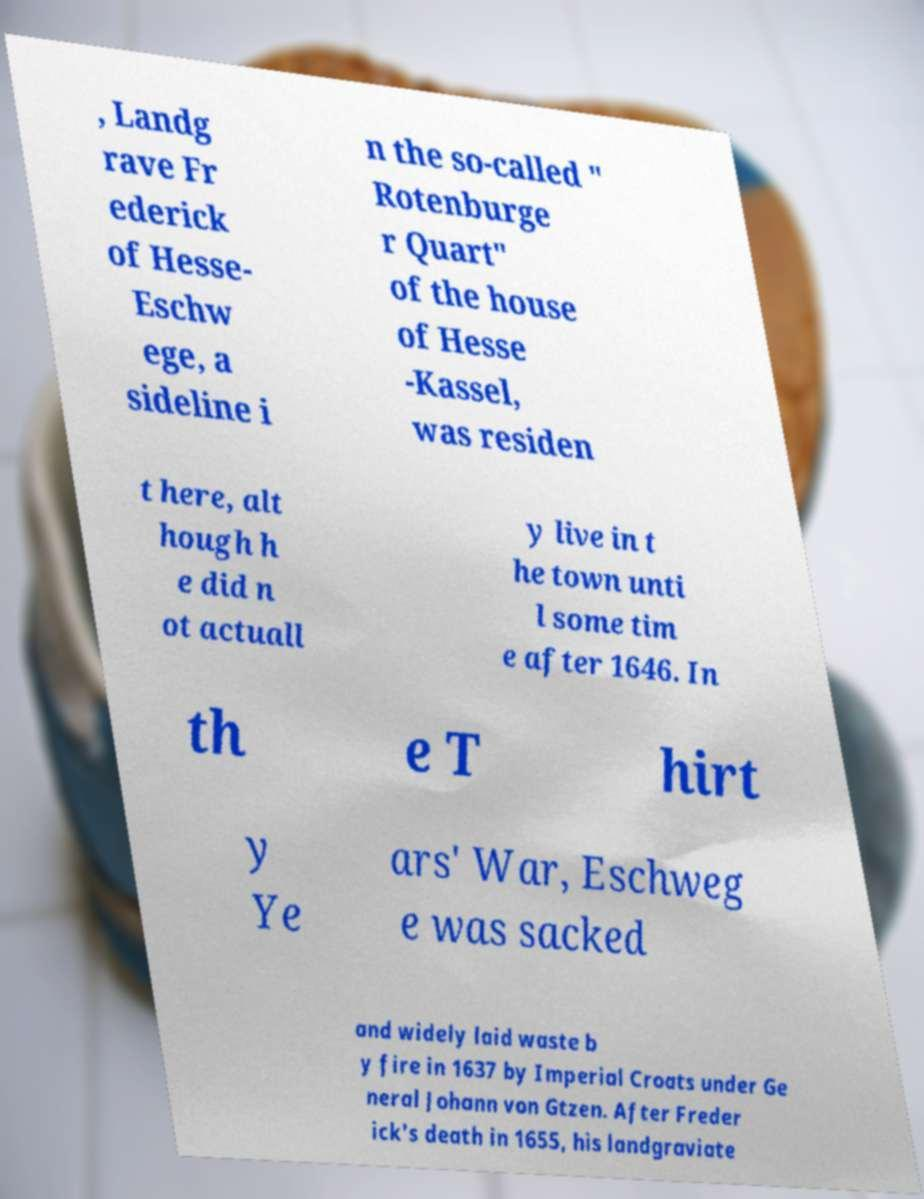I need the written content from this picture converted into text. Can you do that? , Landg rave Fr ederick of Hesse- Eschw ege, a sideline i n the so-called " Rotenburge r Quart" of the house of Hesse -Kassel, was residen t here, alt hough h e did n ot actuall y live in t he town unti l some tim e after 1646. In th e T hirt y Ye ars' War, Eschweg e was sacked and widely laid waste b y fire in 1637 by Imperial Croats under Ge neral Johann von Gtzen. After Freder ick's death in 1655, his landgraviate 